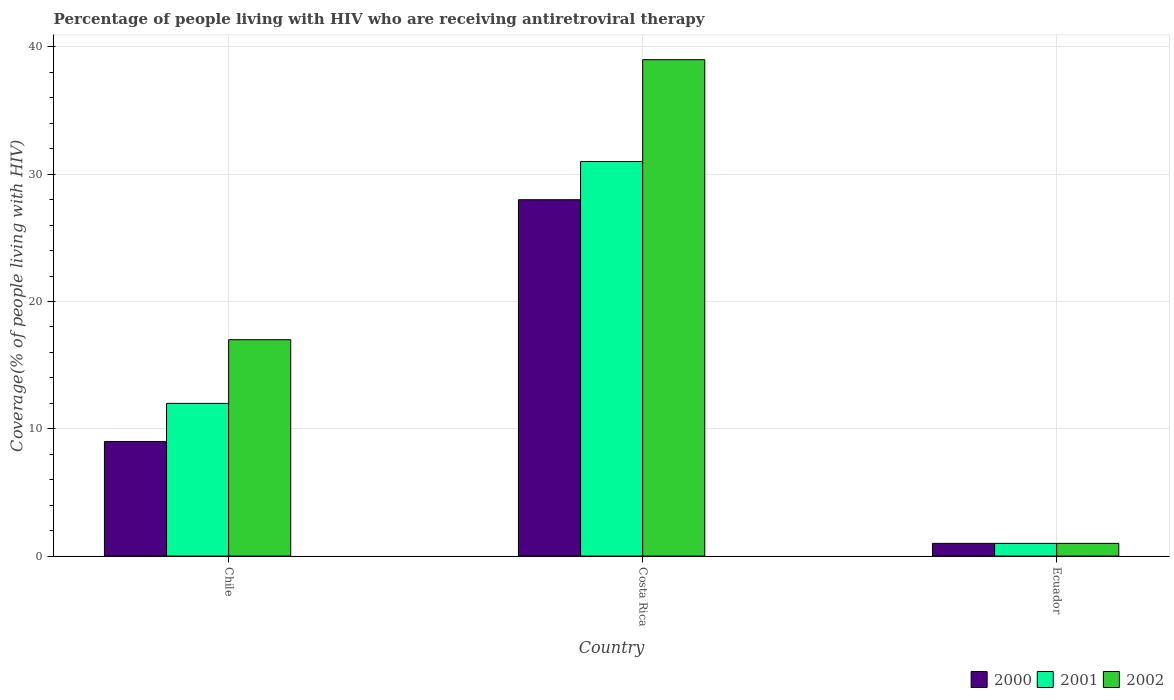Are the number of bars on each tick of the X-axis equal?
Ensure brevity in your answer.  Yes. How many bars are there on the 2nd tick from the left?
Provide a succinct answer. 3. In how many cases, is the number of bars for a given country not equal to the number of legend labels?
Keep it short and to the point. 0. In which country was the percentage of the HIV infected people who are receiving antiretroviral therapy in 2000 maximum?
Your response must be concise. Costa Rica. In which country was the percentage of the HIV infected people who are receiving antiretroviral therapy in 2001 minimum?
Ensure brevity in your answer.  Ecuador. What is the difference between the percentage of the HIV infected people who are receiving antiretroviral therapy in 2000 in Costa Rica and that in Ecuador?
Ensure brevity in your answer.  27. What is the average percentage of the HIV infected people who are receiving antiretroviral therapy in 2000 per country?
Ensure brevity in your answer.  12.67. What is the difference between the percentage of the HIV infected people who are receiving antiretroviral therapy of/in 2001 and percentage of the HIV infected people who are receiving antiretroviral therapy of/in 2000 in Costa Rica?
Keep it short and to the point. 3. In how many countries, is the percentage of the HIV infected people who are receiving antiretroviral therapy in 2000 greater than 38 %?
Offer a very short reply. 0. What is the ratio of the percentage of the HIV infected people who are receiving antiretroviral therapy in 2000 in Chile to that in Costa Rica?
Ensure brevity in your answer.  0.32. Is the percentage of the HIV infected people who are receiving antiretroviral therapy in 2001 in Costa Rica less than that in Ecuador?
Keep it short and to the point. No. What is the difference between the highest and the second highest percentage of the HIV infected people who are receiving antiretroviral therapy in 2002?
Give a very brief answer. 16. Is it the case that in every country, the sum of the percentage of the HIV infected people who are receiving antiretroviral therapy in 2000 and percentage of the HIV infected people who are receiving antiretroviral therapy in 2002 is greater than the percentage of the HIV infected people who are receiving antiretroviral therapy in 2001?
Give a very brief answer. Yes. How many bars are there?
Keep it short and to the point. 9. How many countries are there in the graph?
Offer a terse response. 3. Are the values on the major ticks of Y-axis written in scientific E-notation?
Keep it short and to the point. No. Does the graph contain any zero values?
Ensure brevity in your answer.  No. Does the graph contain grids?
Offer a very short reply. Yes. Where does the legend appear in the graph?
Provide a short and direct response. Bottom right. How many legend labels are there?
Provide a short and direct response. 3. How are the legend labels stacked?
Keep it short and to the point. Horizontal. What is the title of the graph?
Your response must be concise. Percentage of people living with HIV who are receiving antiretroviral therapy. Does "2011" appear as one of the legend labels in the graph?
Your response must be concise. No. What is the label or title of the X-axis?
Provide a succinct answer. Country. What is the label or title of the Y-axis?
Your answer should be compact. Coverage(% of people living with HIV). What is the Coverage(% of people living with HIV) of 2000 in Chile?
Provide a succinct answer. 9. What is the Coverage(% of people living with HIV) of 2001 in Chile?
Ensure brevity in your answer.  12. What is the Coverage(% of people living with HIV) of 2002 in Chile?
Provide a short and direct response. 17. What is the Coverage(% of people living with HIV) in 2000 in Costa Rica?
Keep it short and to the point. 28. What is the Coverage(% of people living with HIV) in 2000 in Ecuador?
Your answer should be compact. 1. Across all countries, what is the maximum Coverage(% of people living with HIV) in 2000?
Your response must be concise. 28. Across all countries, what is the maximum Coverage(% of people living with HIV) in 2001?
Give a very brief answer. 31. Across all countries, what is the maximum Coverage(% of people living with HIV) in 2002?
Your answer should be very brief. 39. Across all countries, what is the minimum Coverage(% of people living with HIV) in 2001?
Give a very brief answer. 1. What is the total Coverage(% of people living with HIV) in 2000 in the graph?
Your response must be concise. 38. What is the difference between the Coverage(% of people living with HIV) of 2000 in Chile and that in Ecuador?
Make the answer very short. 8. What is the difference between the Coverage(% of people living with HIV) in 2001 in Chile and that in Ecuador?
Provide a succinct answer. 11. What is the difference between the Coverage(% of people living with HIV) of 2002 in Chile and that in Ecuador?
Your answer should be compact. 16. What is the difference between the Coverage(% of people living with HIV) in 2001 in Chile and the Coverage(% of people living with HIV) in 2002 in Ecuador?
Give a very brief answer. 11. What is the difference between the Coverage(% of people living with HIV) in 2000 in Costa Rica and the Coverage(% of people living with HIV) in 2001 in Ecuador?
Provide a succinct answer. 27. What is the difference between the Coverage(% of people living with HIV) of 2000 in Costa Rica and the Coverage(% of people living with HIV) of 2002 in Ecuador?
Your answer should be very brief. 27. What is the difference between the Coverage(% of people living with HIV) in 2001 in Costa Rica and the Coverage(% of people living with HIV) in 2002 in Ecuador?
Offer a terse response. 30. What is the average Coverage(% of people living with HIV) of 2000 per country?
Keep it short and to the point. 12.67. What is the average Coverage(% of people living with HIV) of 2001 per country?
Offer a terse response. 14.67. What is the difference between the Coverage(% of people living with HIV) of 2000 and Coverage(% of people living with HIV) of 2001 in Chile?
Provide a succinct answer. -3. What is the difference between the Coverage(% of people living with HIV) in 2000 and Coverage(% of people living with HIV) in 2002 in Chile?
Offer a terse response. -8. What is the ratio of the Coverage(% of people living with HIV) of 2000 in Chile to that in Costa Rica?
Make the answer very short. 0.32. What is the ratio of the Coverage(% of people living with HIV) in 2001 in Chile to that in Costa Rica?
Your answer should be compact. 0.39. What is the ratio of the Coverage(% of people living with HIV) of 2002 in Chile to that in Costa Rica?
Make the answer very short. 0.44. What is the ratio of the Coverage(% of people living with HIV) in 2000 in Chile to that in Ecuador?
Give a very brief answer. 9. What is the ratio of the Coverage(% of people living with HIV) in 2001 in Chile to that in Ecuador?
Ensure brevity in your answer.  12. What is the ratio of the Coverage(% of people living with HIV) of 2002 in Chile to that in Ecuador?
Give a very brief answer. 17. What is the ratio of the Coverage(% of people living with HIV) of 2002 in Costa Rica to that in Ecuador?
Your answer should be very brief. 39. What is the difference between the highest and the lowest Coverage(% of people living with HIV) of 2002?
Make the answer very short. 38. 